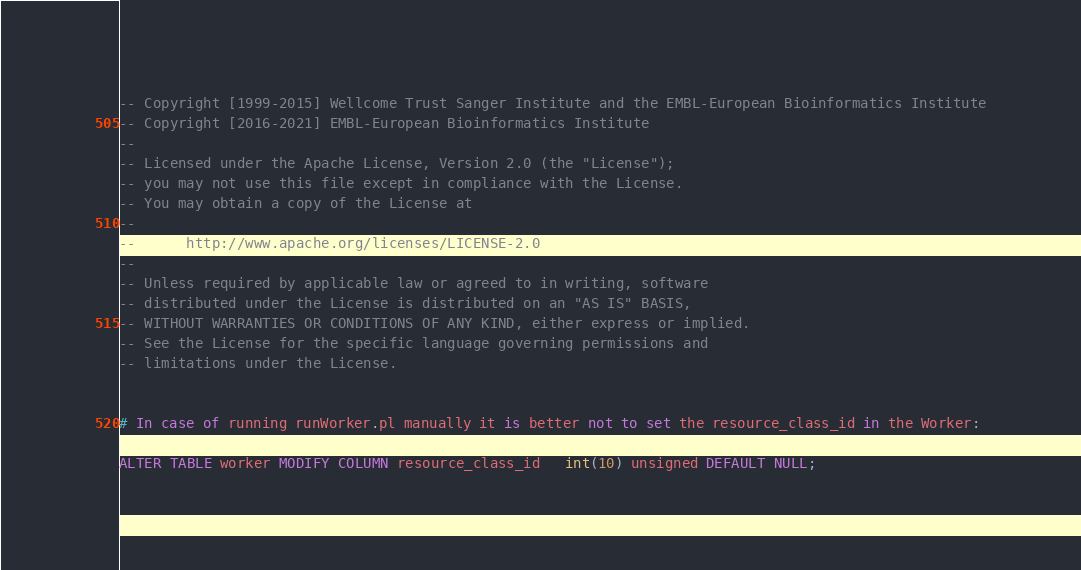<code> <loc_0><loc_0><loc_500><loc_500><_SQL_>-- Copyright [1999-2015] Wellcome Trust Sanger Institute and the EMBL-European Bioinformatics Institute
-- Copyright [2016-2021] EMBL-European Bioinformatics Institute
-- 
-- Licensed under the Apache License, Version 2.0 (the "License");
-- you may not use this file except in compliance with the License.
-- You may obtain a copy of the License at
-- 
--      http://www.apache.org/licenses/LICENSE-2.0
-- 
-- Unless required by applicable law or agreed to in writing, software
-- distributed under the License is distributed on an "AS IS" BASIS,
-- WITHOUT WARRANTIES OR CONDITIONS OF ANY KIND, either express or implied.
-- See the License for the specific language governing permissions and
-- limitations under the License.


# In case of running runWorker.pl manually it is better not to set the resource_class_id in the Worker:

ALTER TABLE worker MODIFY COLUMN resource_class_id   int(10) unsigned DEFAULT NULL;
</code> 